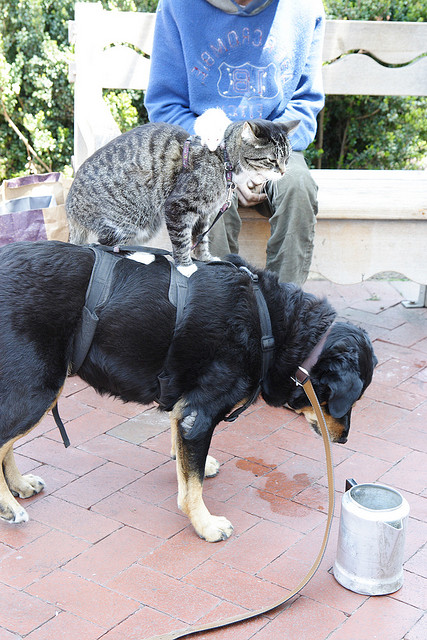<image>What type of dog is shown? I am not sure what type of dog is shown. It can be a hound, border collie, mutt, mixed breed, rottweiler, golden retriever, labrador, or a black lab. What type of dog is shown? I am not sure what type of dog is shown. It can be a hound, border collie, mutt, mixed breed, rottweiler, golden retriever, labrador or black lab. 